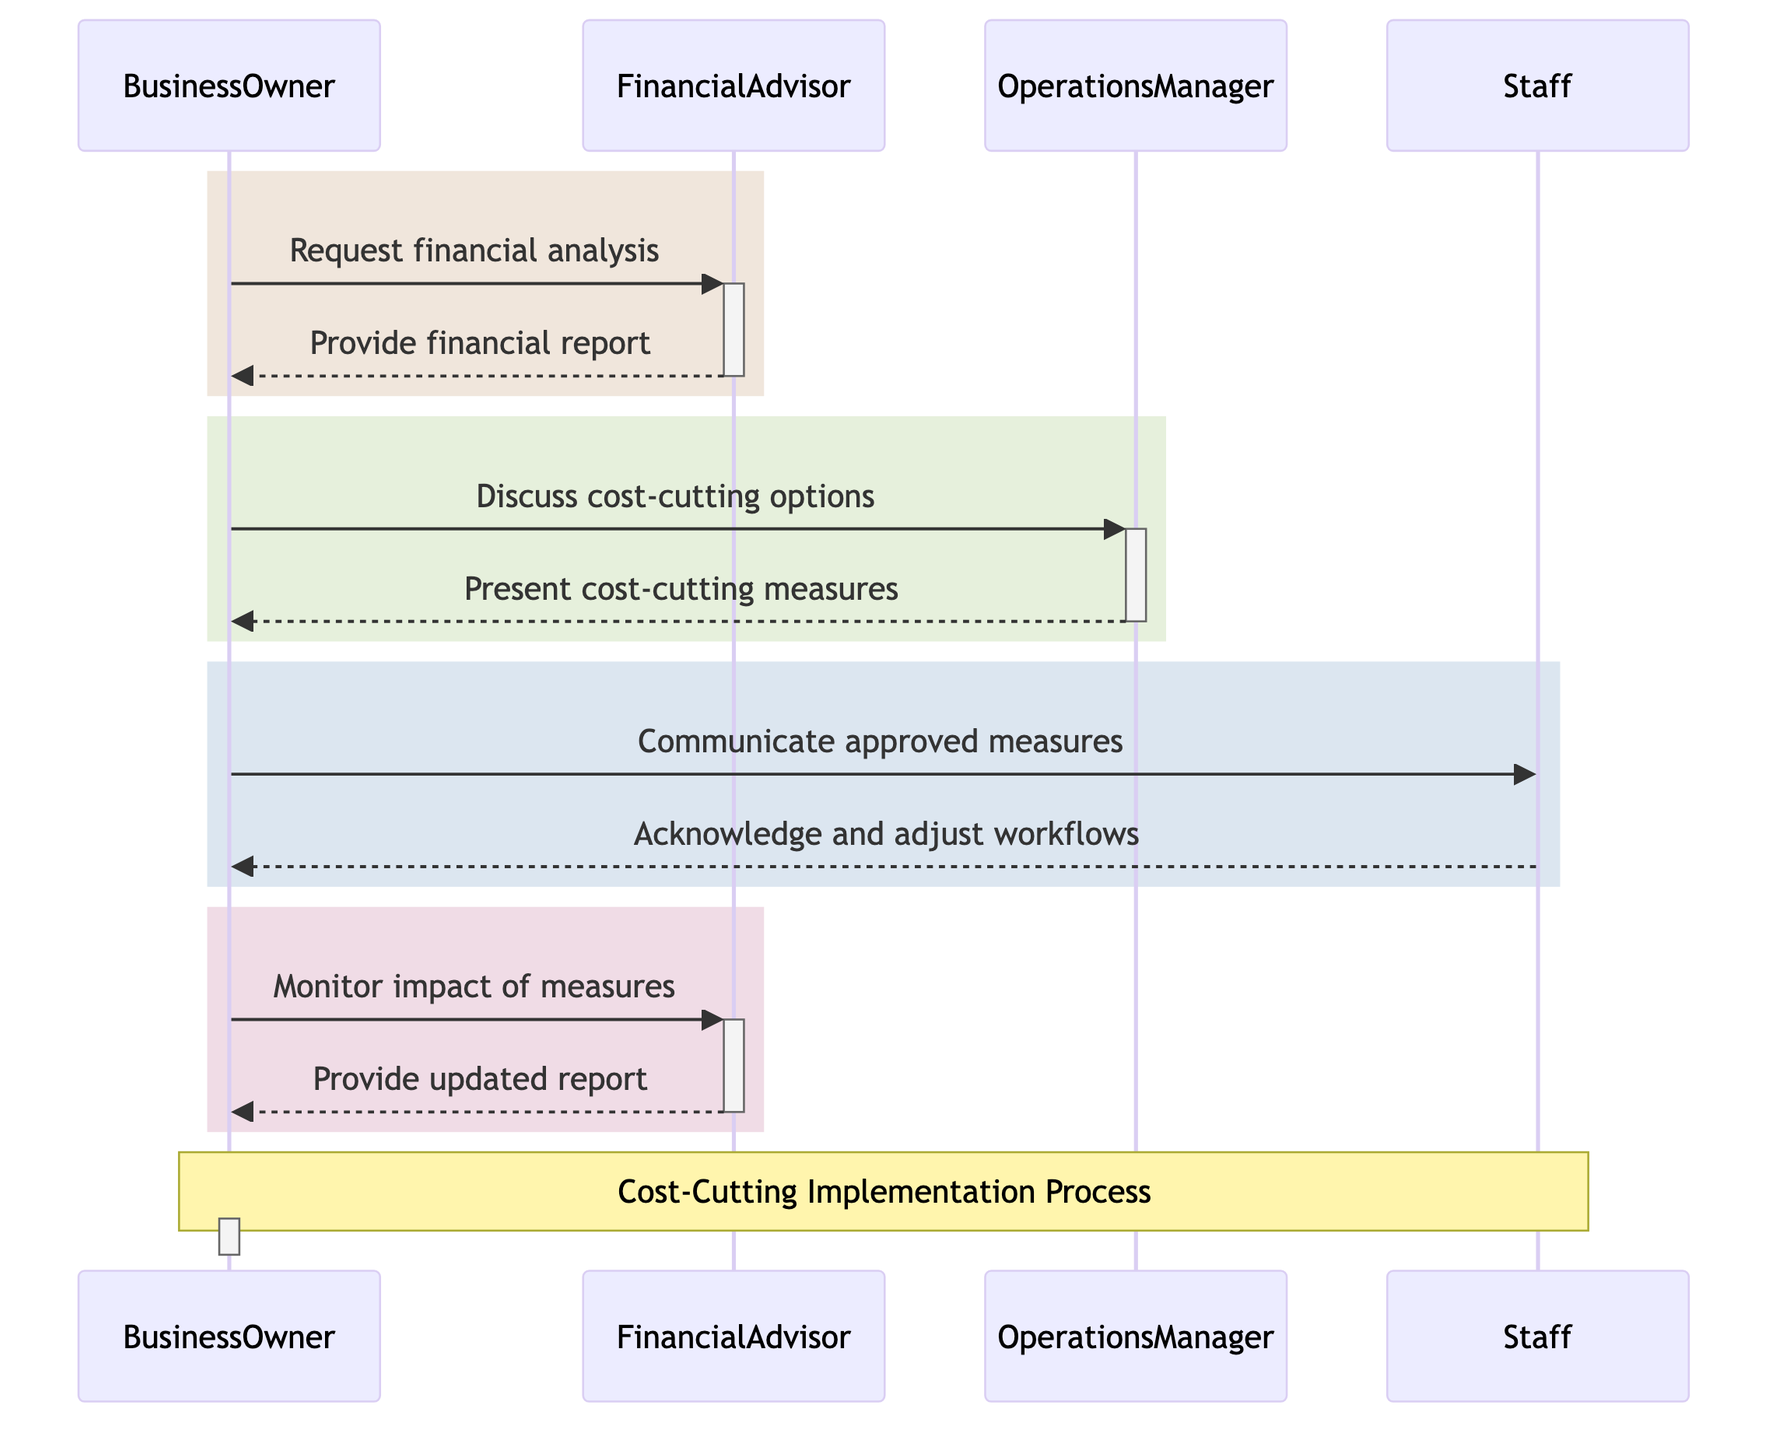What is the first message sent in the sequence? The first message is from the Business Owner to the Financial Advisor, requesting a financial analysis on recent revenues and expenses.
Answer: Request financial analysis on recent revenues and expenses How many actors are present in this sequence diagram? There are four actors present: BusinessOwner, FinancialAdvisor, OperationsManager, and Staff.
Answer: 4 Who does the Operations Manager present the cost-cutting options to? The Operations Manager presents the options for cost-cutting measures directly to the Business Owner.
Answer: BusinessOwner How many steps involve the Financial Advisor in this sequence? The Financial Advisor is involved in three steps: providing the financial analysis report, monitoring the impact of cost-cutting measures, and providing an updated financial report and feedback.
Answer: 3 What action do the Staff take after receiving the communicated measures? The Staff acknowledges the measures and adjusts their workflows based on the new measures communicated by the Business Owner.
Answer: Acknowledge and adjust workflows based on new measures Which actor communicates the approved cost-cutting measures? The Business Owner is responsible for communicating the approved cost-cutting measures to the Staff.
Answer: BusinessOwner What is the primary purpose of the sequence of actions depicted in the diagram? The primary purpose is to illustrate the decision-making process for implementing cost-cutting measures in response to the financial analysis.
Answer: Cost-Cutting Implementation Process 